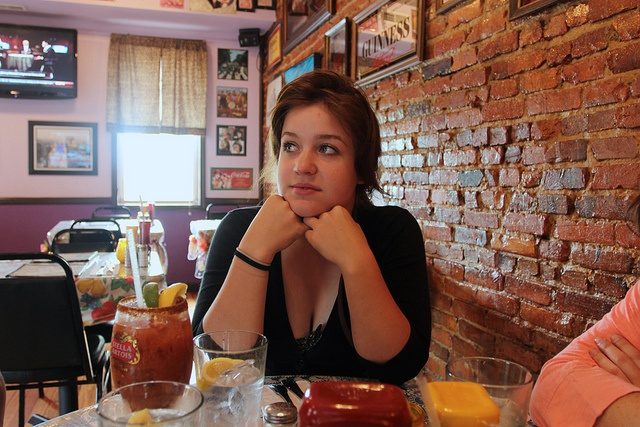Describe the objects in this image and their specific colors. I can see people in gray, black, maroon, and brown tones, dining table in gray, maroon, darkgray, and brown tones, chair in gray, black, darkgray, maroon, and brown tones, people in gray, salmon, brown, and red tones, and tv in gray, white, darkgray, and lightblue tones in this image. 